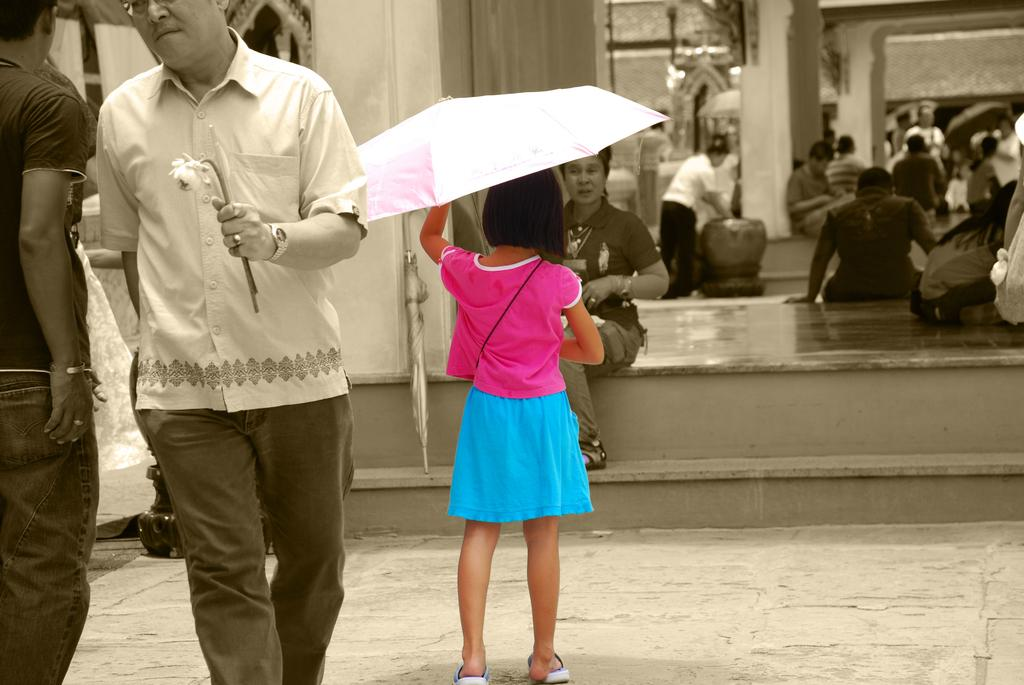Who or what can be seen in the image? There are people and buildings in the image. Can you describe any specific objects or features in the image? There is a white color umbrella in the image. What might the person in the front be holding? A person in the front is holding a flower. What type of engine can be seen powering the flower in the image? There is no engine present in the image, and the flower is not being powered by any engine. 